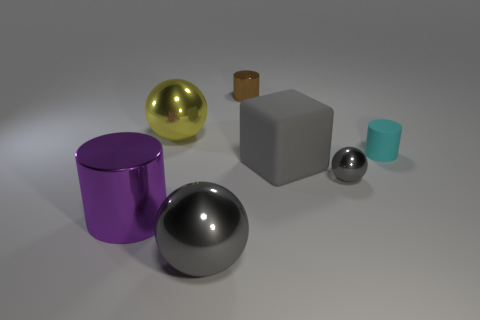There is a matte block; does it have the same color as the big metal thing that is in front of the big purple shiny cylinder?
Your answer should be very brief. Yes. Are there any small spheres that have the same color as the large matte object?
Make the answer very short. Yes. Does the brown thing have the same material as the tiny cylinder that is in front of the brown metal cylinder?
Offer a terse response. No. What number of large things are gray rubber things or red matte cylinders?
Provide a succinct answer. 1. What is the material of the cube that is the same color as the tiny metal sphere?
Keep it short and to the point. Rubber. Is the number of small cyan cylinders less than the number of gray shiny things?
Give a very brief answer. Yes. Does the gray sphere that is to the left of the big block have the same size as the sphere that is left of the large gray ball?
Offer a very short reply. Yes. How many purple objects are either tiny spheres or small shiny cylinders?
Offer a terse response. 0. What is the size of the shiny object that is the same color as the small ball?
Your response must be concise. Large. Are there more small green matte spheres than yellow balls?
Ensure brevity in your answer.  No. 